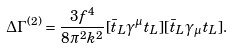Convert formula to latex. <formula><loc_0><loc_0><loc_500><loc_500>\Delta \Gamma ^ { ( 2 ) } = \frac { 3 f ^ { 4 } } { 8 \pi ^ { 2 } k ^ { 2 } } [ \bar { t } _ { L } \gamma ^ { \mu } t _ { L } ] [ \bar { t } _ { L } \gamma _ { \mu } t _ { L } ] .</formula> 